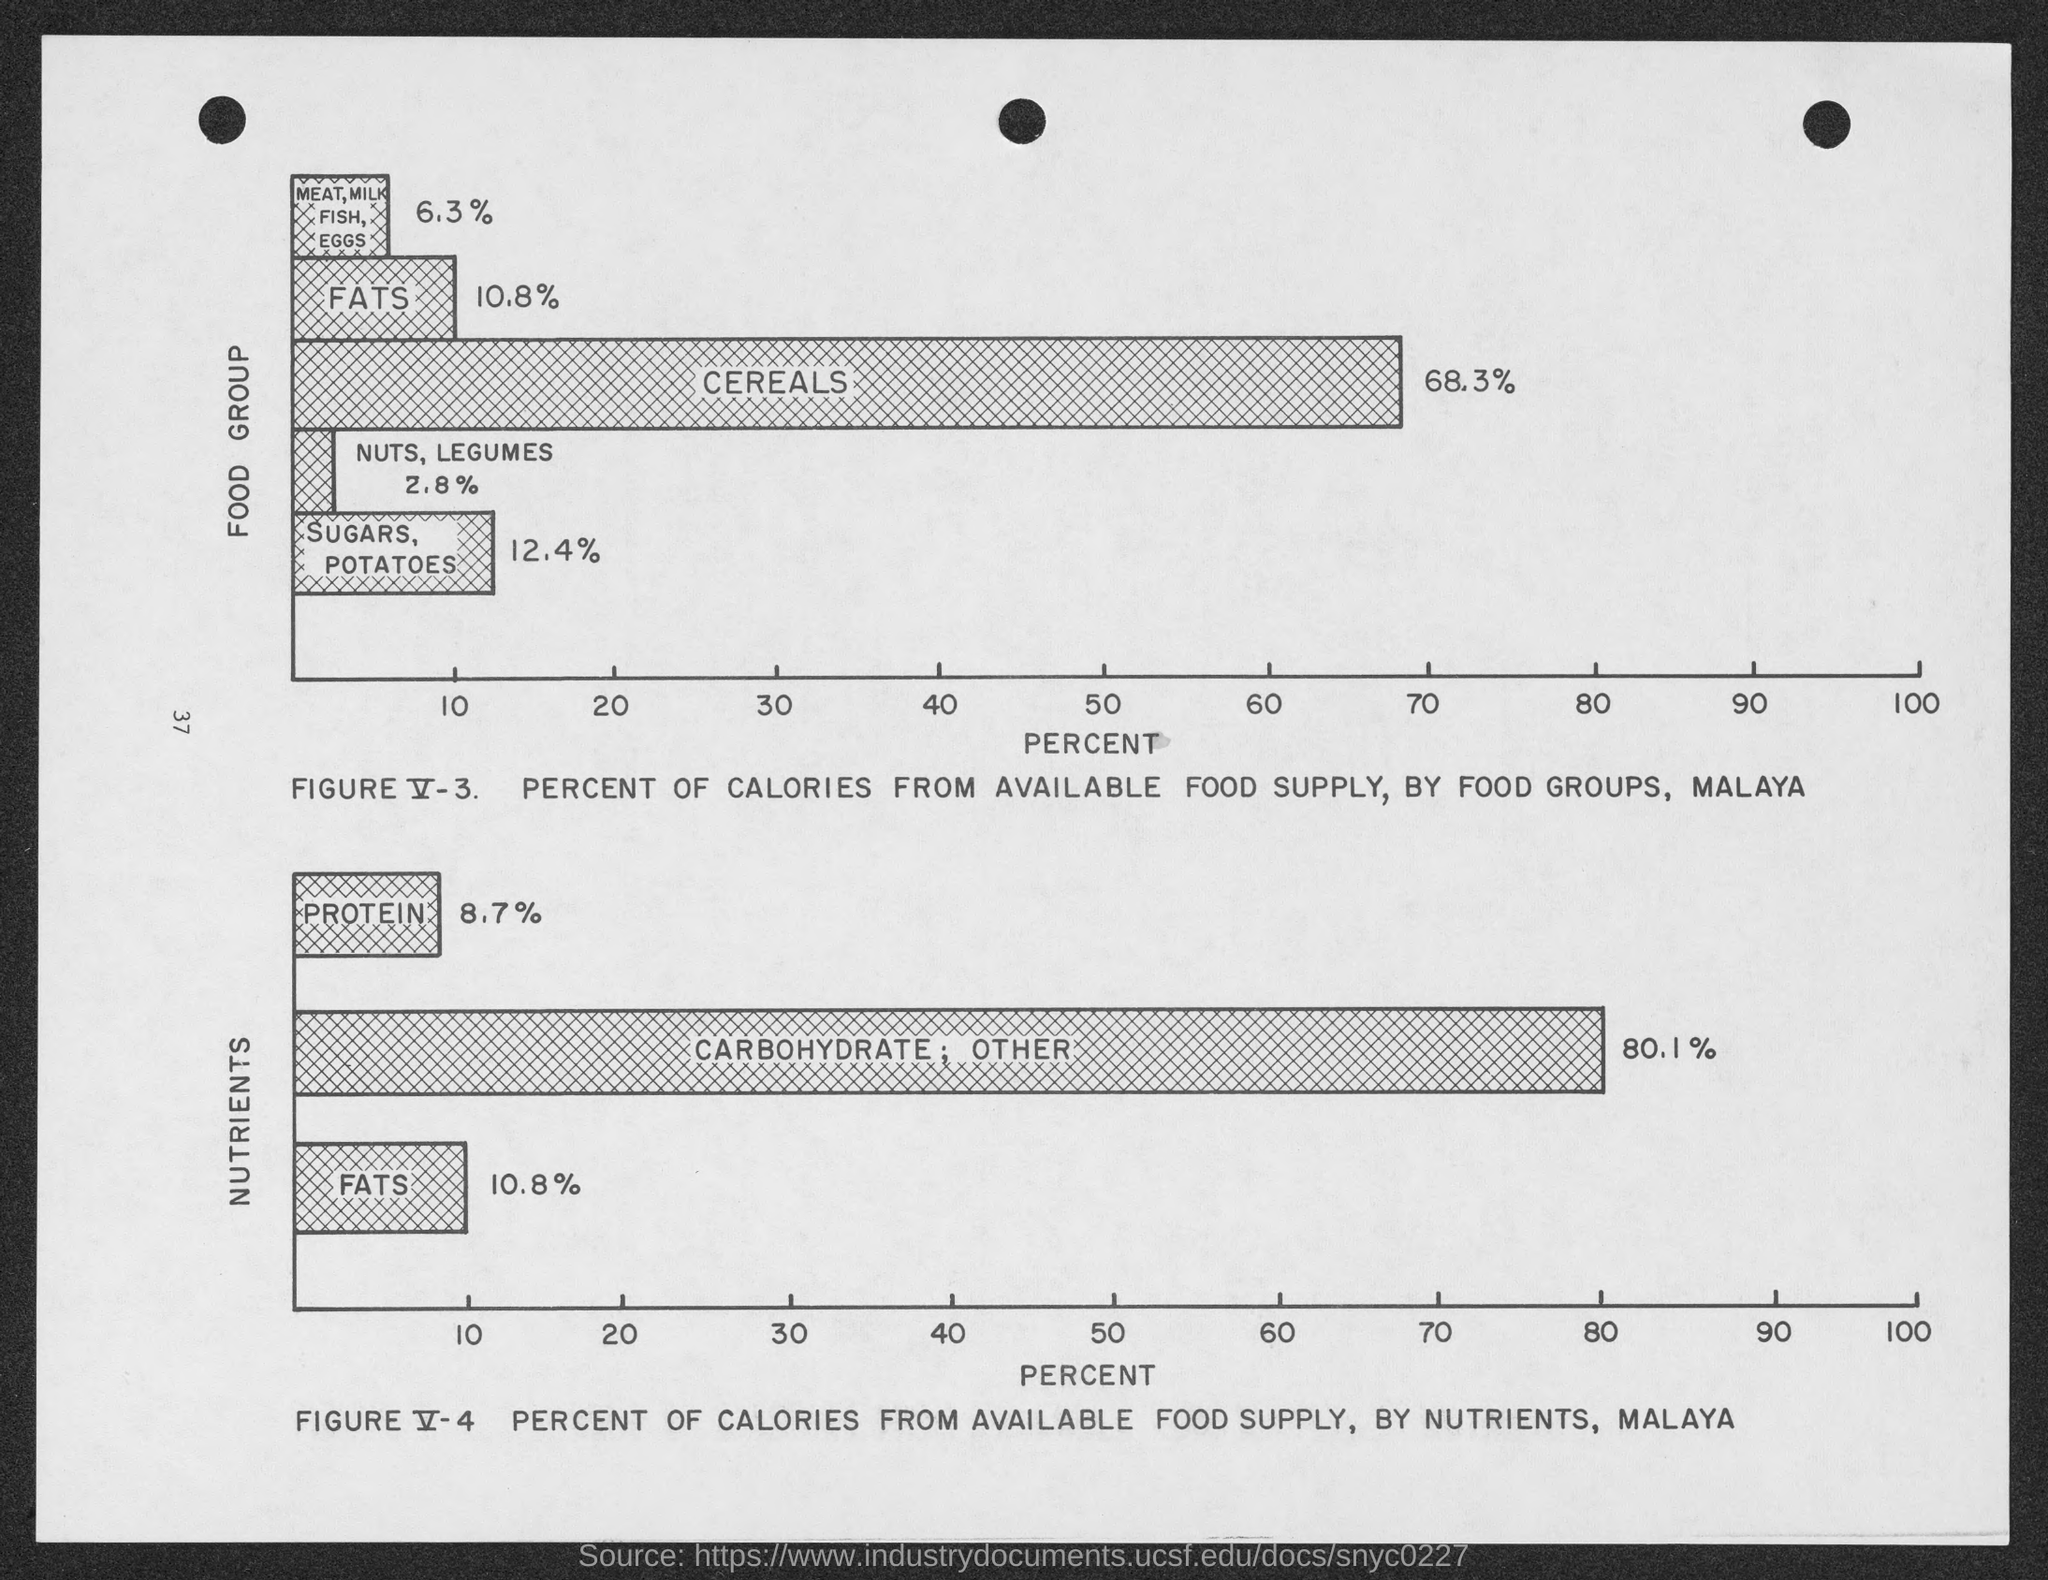What is the percent of meat, milk, fish, eggs in food group?
Your response must be concise. 6.3%. What is the percent of fats in food group?
Provide a succinct answer. 10.8%. What is the percent of cereals in food group?
Your response must be concise. 68.3%. What is the percent of nuts, legumes in food group?
Your response must be concise. 2.8%. What is the percent of sugars, potatoes ?
Give a very brief answer. 12.4%. What is the percent of protein in nutrients ?
Ensure brevity in your answer.  8.7%. What is the percent of carbohydrate, other in nutrients  ?
Offer a terse response. 80.1%. What is the percent of fats in nutrients ?
Your response must be concise. 10.8%. What is the number to left-center of the page ?
Ensure brevity in your answer.  37. 